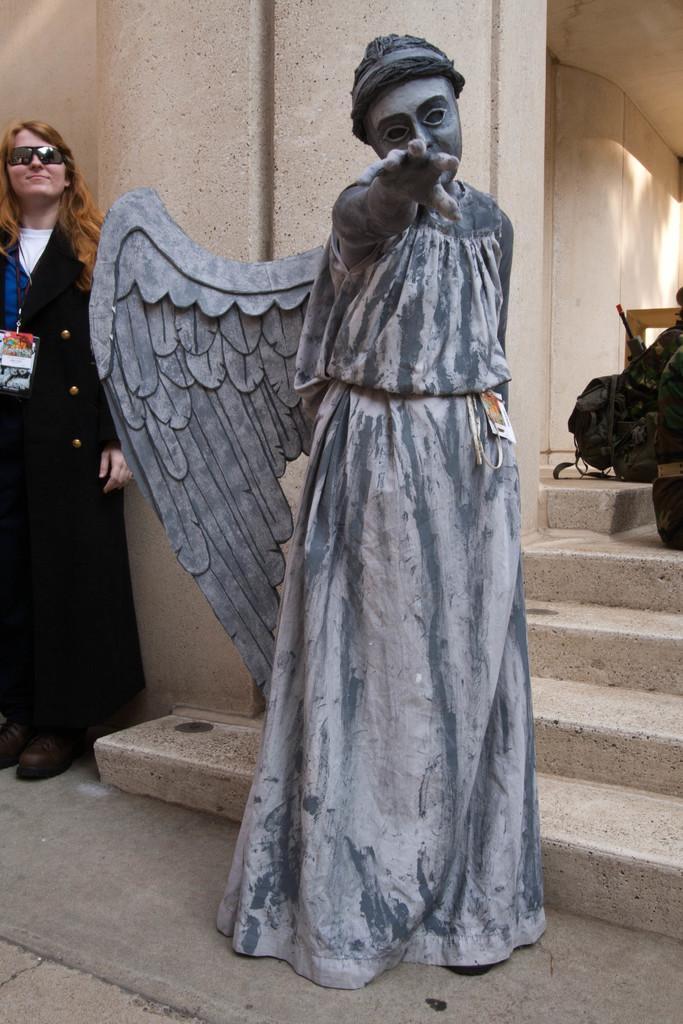How would you summarize this image in a sentence or two? In this image I can see a sculpture in the front and behind it I can see stairs. On the left side of this image I can see a woman is standing and I can see she is wearing black colour coat, an ID card and black shades. On the right side of this image I can see few things. 